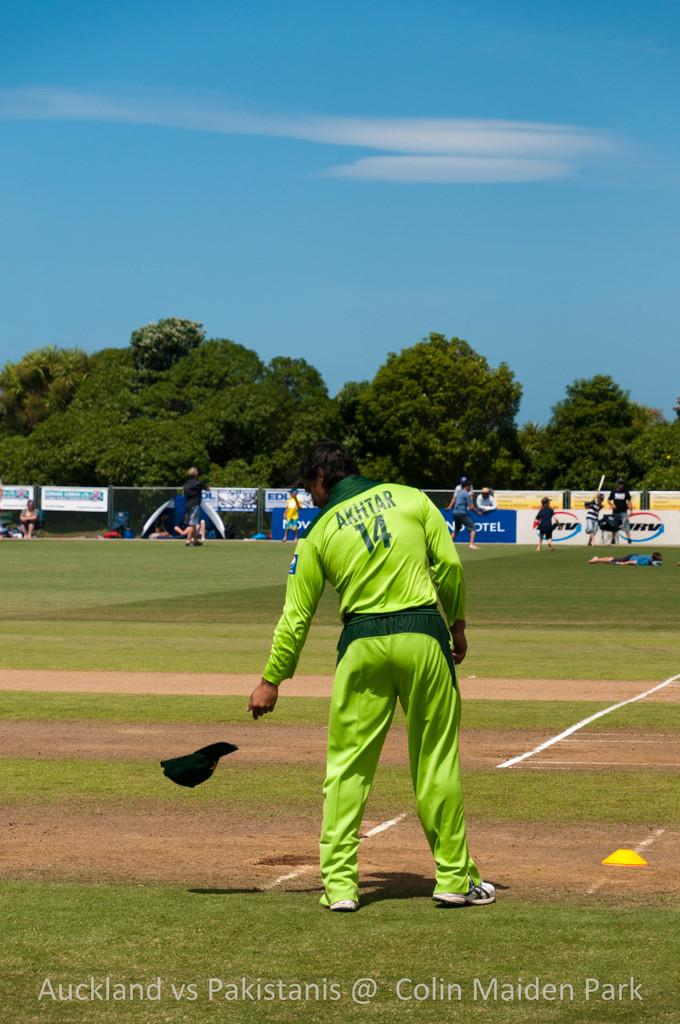<image>
Give a short and clear explanation of the subsequent image. A baseball player in a green uniform with the number 14 on his back is standing on a base. 